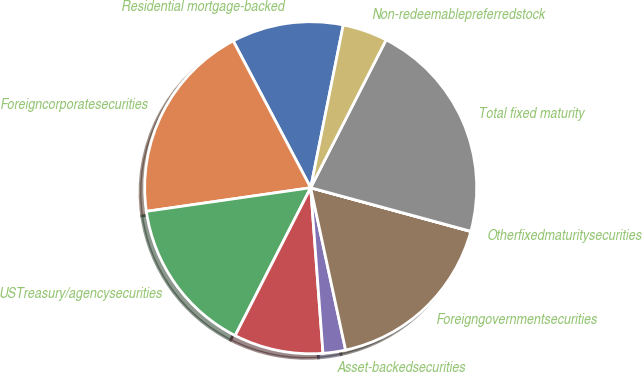<chart> <loc_0><loc_0><loc_500><loc_500><pie_chart><fcel>Residential mortgage-backed<fcel>Foreigncorporatesecurities<fcel>USTreasury/agencysecurities<fcel>Unnamed: 3<fcel>Asset-backedsecurities<fcel>Foreigngovernmentsecurities<fcel>Otherfixedmaturitysecurities<fcel>Total fixed maturity<fcel>Non-redeemablepreferredstock<nl><fcel>10.87%<fcel>19.55%<fcel>15.21%<fcel>8.7%<fcel>2.19%<fcel>17.38%<fcel>0.02%<fcel>21.72%<fcel>4.36%<nl></chart> 